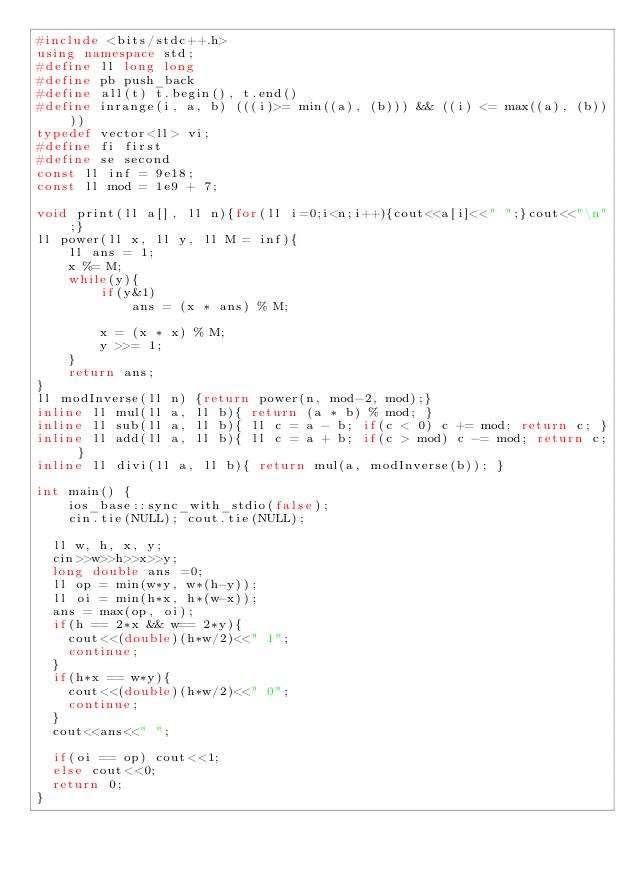Convert code to text. <code><loc_0><loc_0><loc_500><loc_500><_C++_>#include <bits/stdc++.h>
using namespace std;
#define ll long long
#define pb push_back
#define all(t) t.begin(), t.end()
#define inrange(i, a, b) (((i)>= min((a), (b))) && ((i) <= max((a), (b))))
typedef vector<ll> vi;
#define fi first
#define se second
const ll inf = 9e18;
const ll mod = 1e9 + 7;

void print(ll a[], ll n){for(ll i=0;i<n;i++){cout<<a[i]<<" ";}cout<<"\n";}
ll power(ll x, ll y, ll M = inf){
    ll ans = 1;
    x %= M;
    while(y){
        if(y&1)
            ans = (x * ans) % M;

        x = (x * x) % M;
        y >>= 1;
    }
    return ans;
}
ll modInverse(ll n) {return power(n, mod-2, mod);}
inline ll mul(ll a, ll b){ return (a * b) % mod; }
inline ll sub(ll a, ll b){ ll c = a - b; if(c < 0) c += mod; return c; }
inline ll add(ll a, ll b){ ll c = a + b; if(c > mod) c -= mod; return c; }
inline ll divi(ll a, ll b){ return mul(a, modInverse(b)); }

int main() {
    ios_base::sync_with_stdio(false);
    cin.tie(NULL); cout.tie(NULL);

	ll w, h, x, y;
	cin>>w>>h>>x>>y;
	long double ans =0;
	ll op = min(w*y, w*(h-y));
	ll oi = min(h*x, h*(w-x));
	ans = max(op, oi);
	if(h == 2*x && w== 2*y){
		cout<<(double)(h*w/2)<<" 1";
		continue;
	}
	if(h*x == w*y){
		cout<<(double)(h*w/2)<<" 0";
		continue;
	}
	cout<<ans<<" ";

	if(oi == op) cout<<1;
	else cout<<0;
	return 0;
}
</code> 